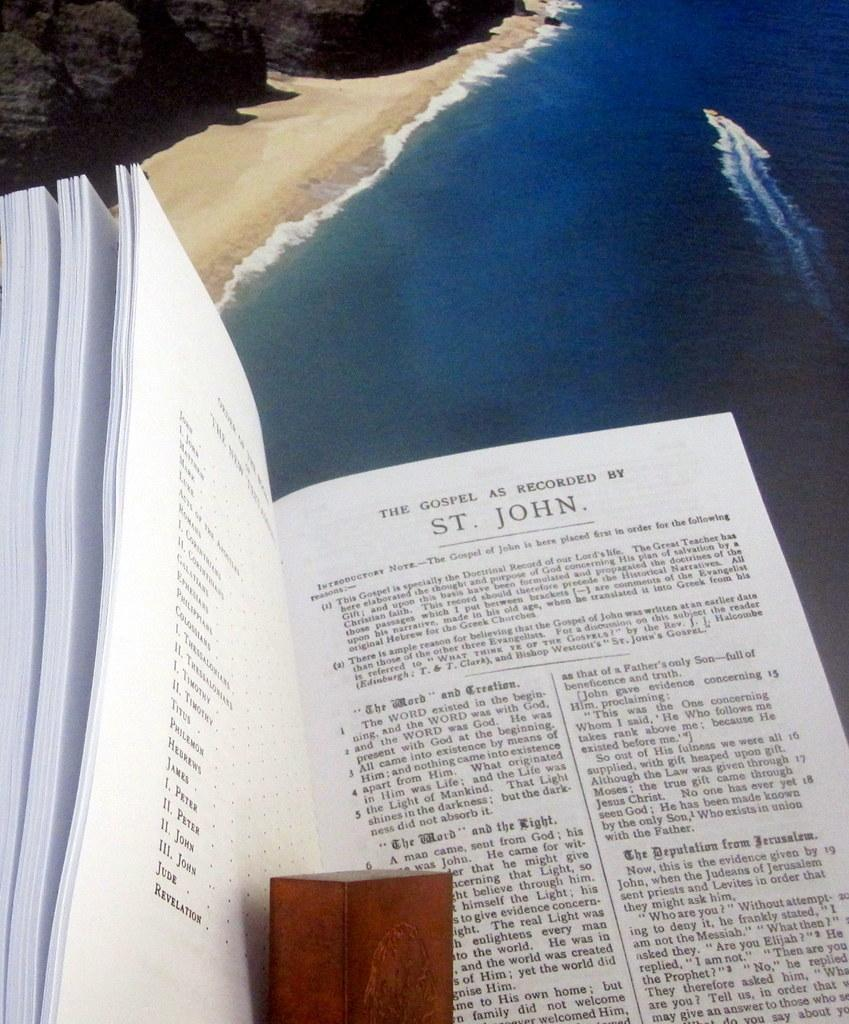<image>
Render a clear and concise summary of the photo. A book is open to a page that begins with the gospel by St. John. 